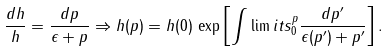Convert formula to latex. <formula><loc_0><loc_0><loc_500><loc_500>\frac { d h } { h } = \frac { d p } { \epsilon + p } \Rightarrow h ( p ) = h ( 0 ) \, \exp \left [ \int \lim i t s _ { 0 } ^ { p } \frac { d p ^ { \prime } } { \epsilon ( p ^ { \prime } ) + p ^ { \prime } } \right ] .</formula> 